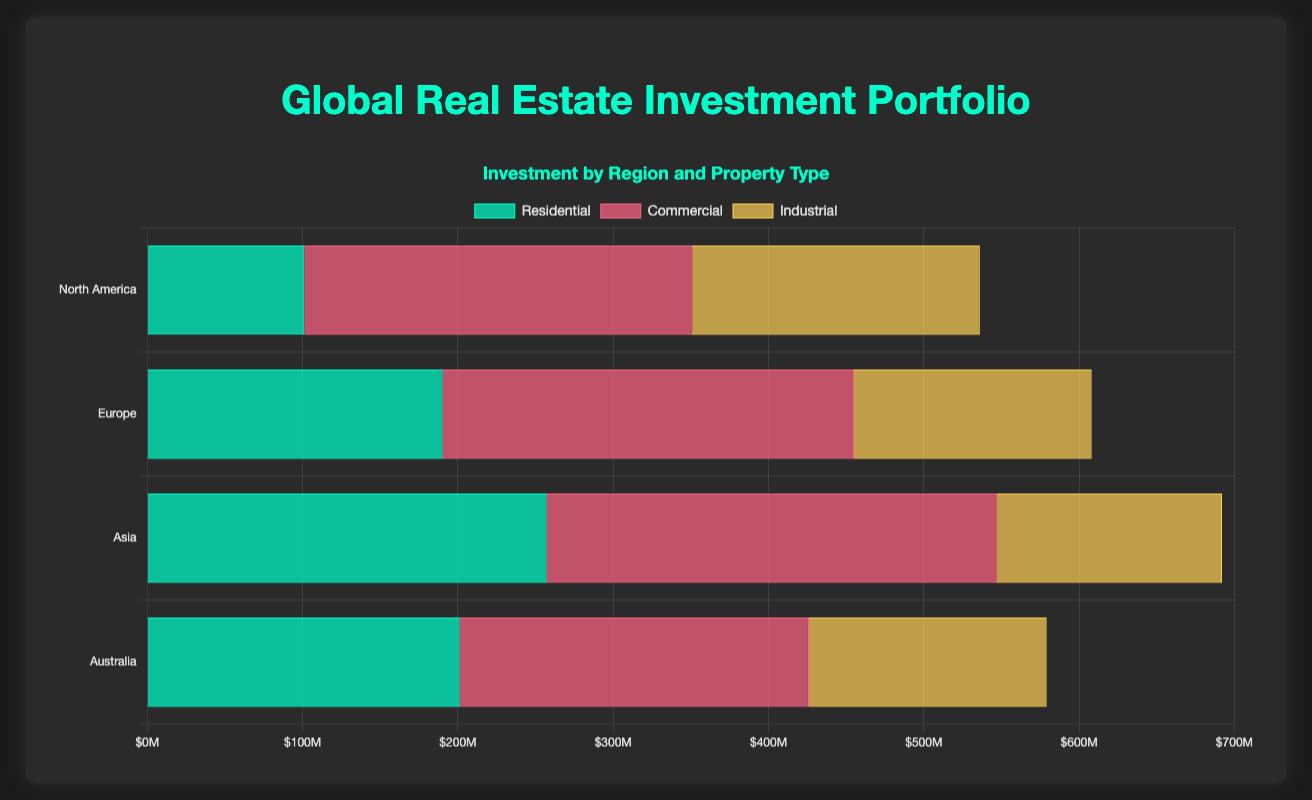Which region has the highest total investment in commercial properties? To find this, identify the bars representing commercial investments in each region. Compare the heights or lengths of these bars. Asia's commercial bar (Shanghai, Mumbai, Dubai) is higher than the others.
Answer: Asia Which property type has the smallest total investment in Europe? Sum the investments for each property type in Europe (Residential, Commercial, Industrial). Compare the sums and find the smallest. Residential: €190M, Commercial: €265M, Industrial: €153M.
Answer: Industrial What is the total investment in Residential properties across all regions? Sum the residential investments of all regions: North America (€101M), Europe (€190M), Asia (€257M), Australia (€201M). 101 + 190 + 257 + 201 = 749.
Answer: €749M Which region has the least investment in Industrial properties? Compare the lengths of the bars representing Industrial investments across regions. Europe has the least with (Hamburg, Rotterdam, Milan) totaling €153M.
Answer: Europe How does the commercial investment in North America compare to Europe? Compare the lengths of the Commercial investment bars for North America and Europe. North America's commercial investment (€250M) is higher than Europe's (€265M).
Answer: Less Which property type has the largest single investment in North America? Identify the tallest/longest bar within North America's property types. The New York Financial District Office Towers in Commercial (€120M) is the highest.
Answer: Commercial What is the average investment in Industrial properties in Australia? Sum up Australia’s Industrial properties (€55M for Sydney, 50M for Melbourne, 48M for Brisbane) and divide by the number of points (3): (55 + 50 + 48) / 3 = 51.
Answer: €51M Compare residential investments between Sydney and Tokyo. Compare the specific figures: Sydney (€86M), Tokyo (€92M). Tokyo has a higher investment.
Answer: Tokyo Combine the total investments in Commercial and Industrial properties in Asia. Which region has a greater respective combined investment you have calculated? Asia Industrial: (€60M, €40M, €45M) = €145M. Commercial: (€130M, €70M, €90M) = €290M. Combined: 145 + 290 = €435M. Compare this with the Commercial and Industrial investments of other regions (North America, Europe, Australia); no region surpasses €435M in the combined total.
Answer: Asia What visual pattern can be seen comparing North America's Industrial investment to Europe’s? By visually inspecting the plot, industrial investments in North America (dark green shade) are longer/taller compared to Europe’s respective bar. This indicates higher investment amounts in North America for this property type.
Answer: North America has higher 